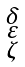<formula> <loc_0><loc_0><loc_500><loc_500>\begin{smallmatrix} \delta \\ \varepsilon \\ \zeta \end{smallmatrix}</formula> 